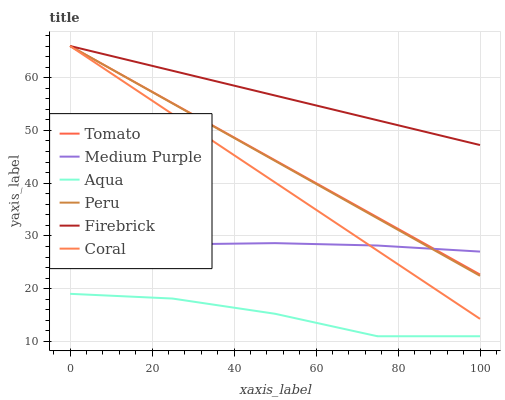Does Aqua have the minimum area under the curve?
Answer yes or no. Yes. Does Firebrick have the maximum area under the curve?
Answer yes or no. Yes. Does Firebrick have the minimum area under the curve?
Answer yes or no. No. Does Aqua have the maximum area under the curve?
Answer yes or no. No. Is Coral the smoothest?
Answer yes or no. Yes. Is Aqua the roughest?
Answer yes or no. Yes. Is Firebrick the smoothest?
Answer yes or no. No. Is Firebrick the roughest?
Answer yes or no. No. Does Firebrick have the lowest value?
Answer yes or no. No. Does Coral have the highest value?
Answer yes or no. Yes. Does Aqua have the highest value?
Answer yes or no. No. Is Aqua less than Coral?
Answer yes or no. Yes. Is Firebrick greater than Aqua?
Answer yes or no. Yes. Does Peru intersect Firebrick?
Answer yes or no. Yes. Is Peru less than Firebrick?
Answer yes or no. No. Is Peru greater than Firebrick?
Answer yes or no. No. Does Aqua intersect Coral?
Answer yes or no. No. 